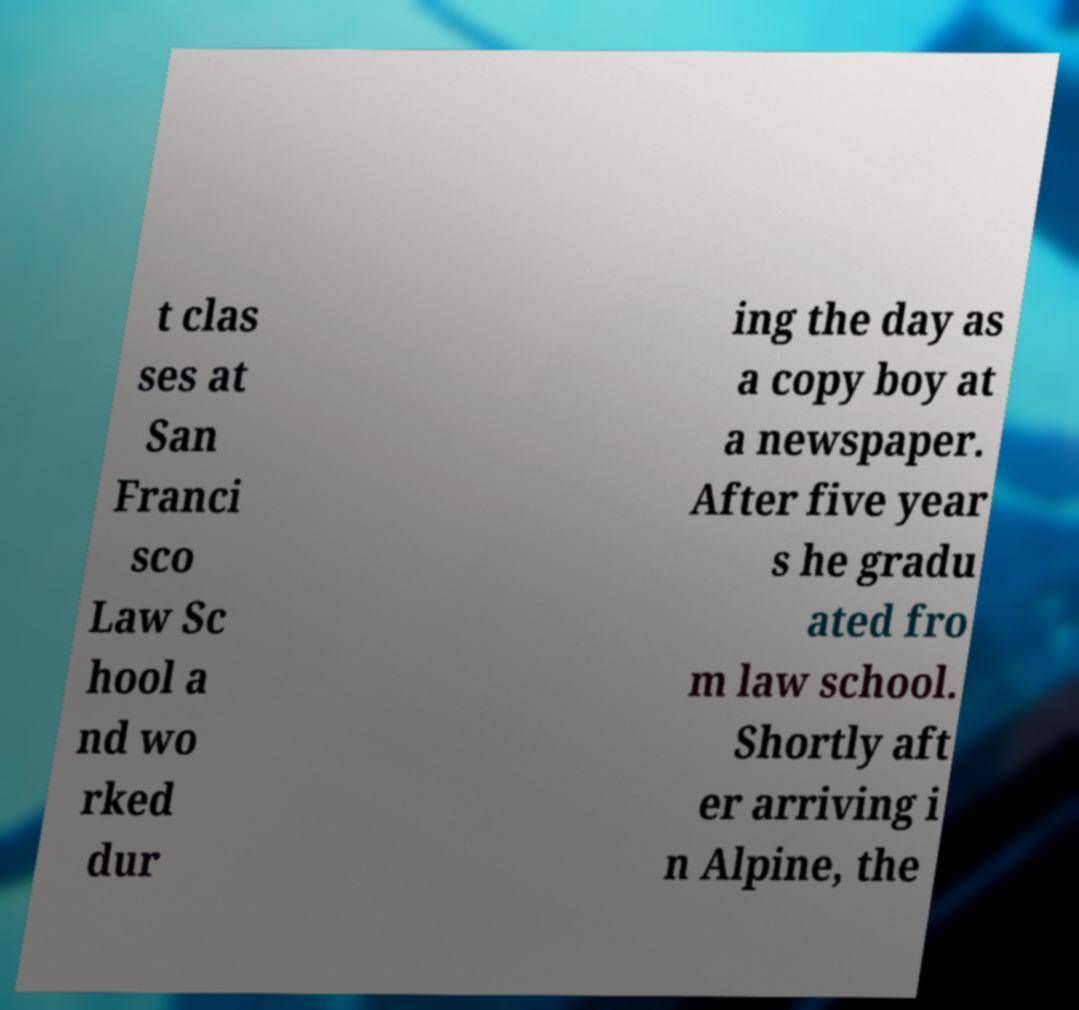Could you assist in decoding the text presented in this image and type it out clearly? t clas ses at San Franci sco Law Sc hool a nd wo rked dur ing the day as a copy boy at a newspaper. After five year s he gradu ated fro m law school. Shortly aft er arriving i n Alpine, the 